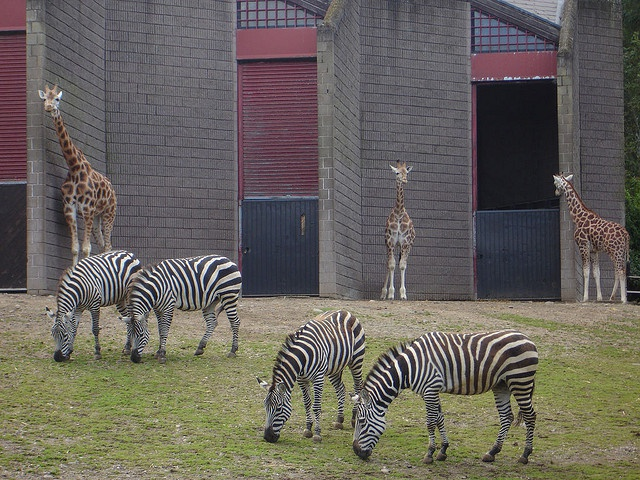Describe the objects in this image and their specific colors. I can see zebra in brown, black, gray, darkgray, and olive tones, zebra in brown, gray, black, darkgray, and navy tones, zebra in brown, black, gray, and darkgray tones, zebra in brown, gray, black, darkgray, and ivory tones, and giraffe in brown, gray, darkgray, and maroon tones in this image. 